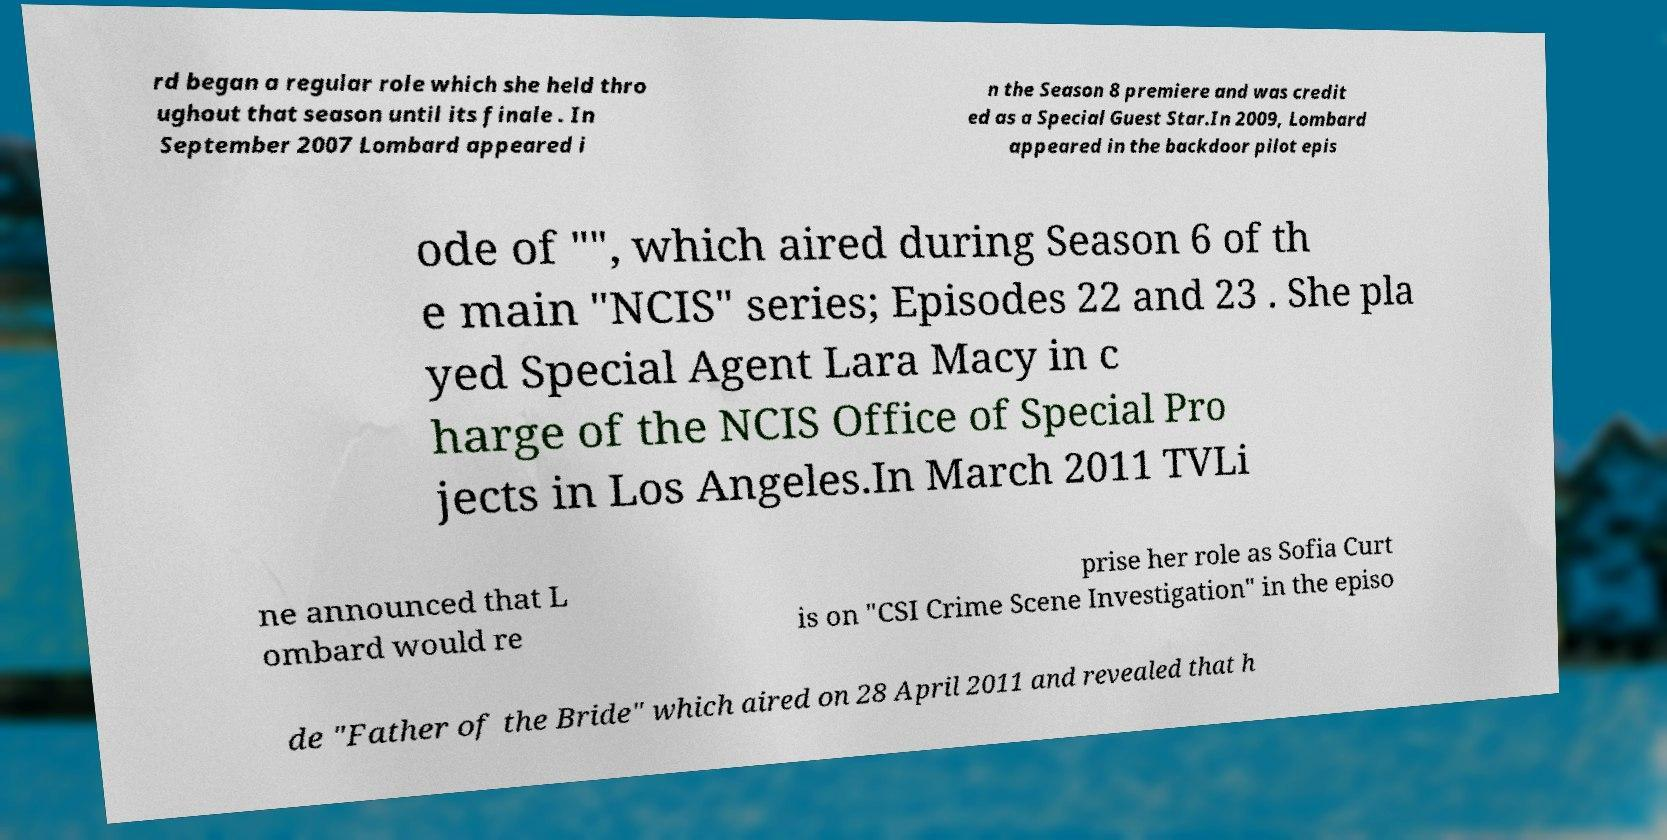Please identify and transcribe the text found in this image. rd began a regular role which she held thro ughout that season until its finale . In September 2007 Lombard appeared i n the Season 8 premiere and was credit ed as a Special Guest Star.In 2009, Lombard appeared in the backdoor pilot epis ode of "", which aired during Season 6 of th e main "NCIS" series; Episodes 22 and 23 . She pla yed Special Agent Lara Macy in c harge of the NCIS Office of Special Pro jects in Los Angeles.In March 2011 TVLi ne announced that L ombard would re prise her role as Sofia Curt is on "CSI Crime Scene Investigation" in the episo de "Father of the Bride" which aired on 28 April 2011 and revealed that h 